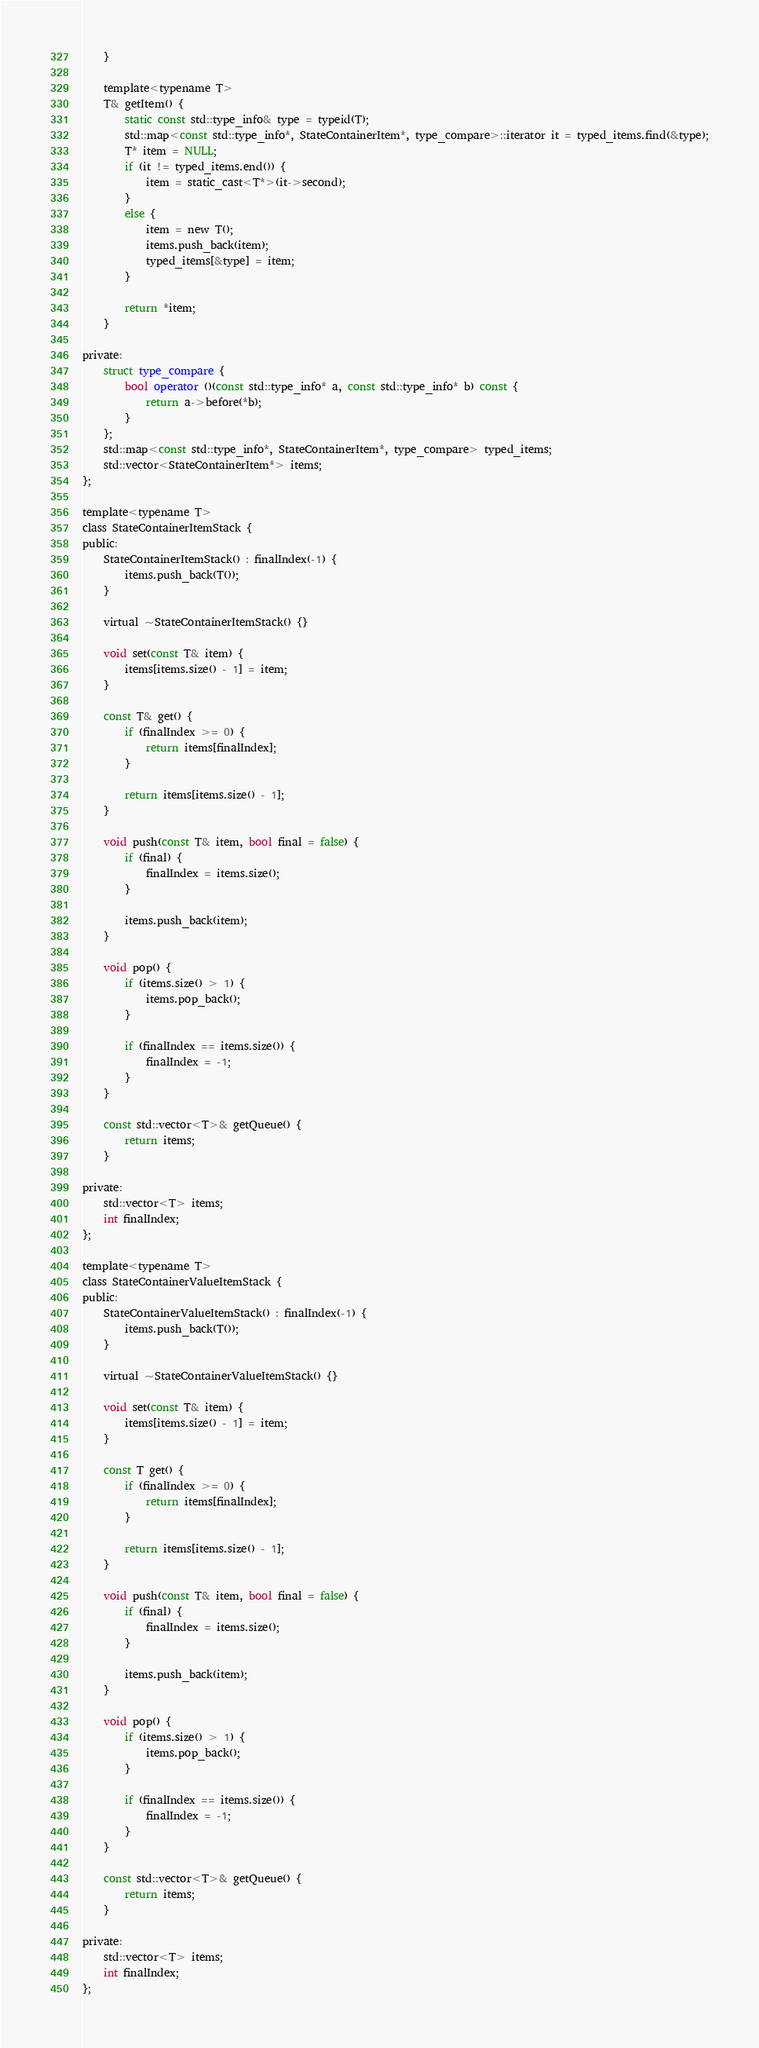Convert code to text. <code><loc_0><loc_0><loc_500><loc_500><_C_>	}

	template<typename T>
	T& getItem() {
		static const std::type_info& type = typeid(T);
		std::map<const std::type_info*, StateContainerItem*, type_compare>::iterator it = typed_items.find(&type);
		T* item = NULL;
		if (it != typed_items.end()) {
			item = static_cast<T*>(it->second);
		}
		else {
			item = new T();
			items.push_back(item);
			typed_items[&type] = item;
		}

		return *item;
	}

private:
	struct type_compare {
	    bool operator ()(const std::type_info* a, const std::type_info* b) const {
	        return a->before(*b);
	    }
	};
	std::map<const std::type_info*, StateContainerItem*, type_compare> typed_items;
	std::vector<StateContainerItem*> items;
};

template<typename T>
class StateContainerItemStack {
public:
	StateContainerItemStack() : finalIndex(-1) {
		items.push_back(T());
	}

	virtual ~StateContainerItemStack() {}

	void set(const T& item) {
		items[items.size() - 1] = item;
	}

	const T& get() {
		if (finalIndex >= 0) {
			return items[finalIndex];
		}

		return items[items.size() - 1];
	}

	void push(const T& item, bool final = false) {
		if (final) {
			finalIndex = items.size();
		}

		items.push_back(item);
	}

	void pop() {
		if (items.size() > 1) {
			items.pop_back();
		}

		if (finalIndex == items.size()) {
			finalIndex = -1;	
		}
	}

	const std::vector<T>& getQueue() {
		return items;
	}

private:
	std::vector<T> items;
	int finalIndex;
};

template<typename T>
class StateContainerValueItemStack {
public:
	StateContainerValueItemStack() : finalIndex(-1) {
		items.push_back(T());
	}

	virtual ~StateContainerValueItemStack() {}

	void set(const T& item) {
		items[items.size() - 1] = item;
	}

	const T get() {
		if (finalIndex >= 0) {
			return items[finalIndex];
		}

		return items[items.size() - 1];
	}

	void push(const T& item, bool final = false) {
		if (final) {
			finalIndex = items.size();
		}

		items.push_back(item);
	}

	void pop() {
		if (items.size() > 1) {
			items.pop_back();
		}

		if (finalIndex == items.size()) {
			finalIndex = -1;	
		}
	}

	const std::vector<T>& getQueue() {
		return items;
	}

private:
	std::vector<T> items;
	int finalIndex;
};
</code> 